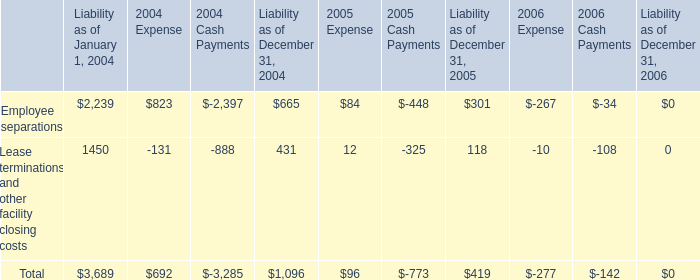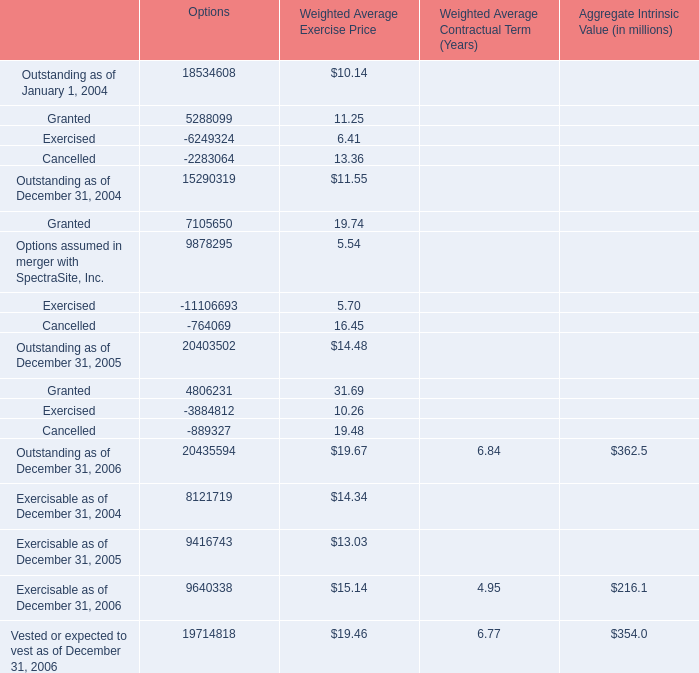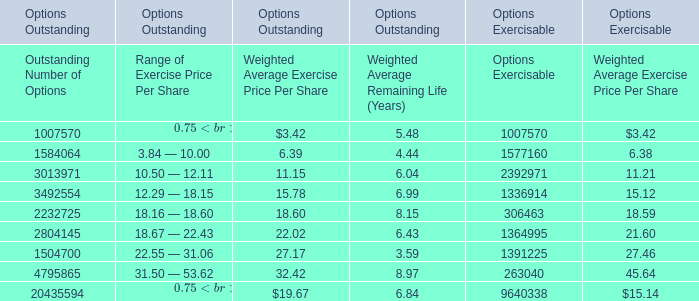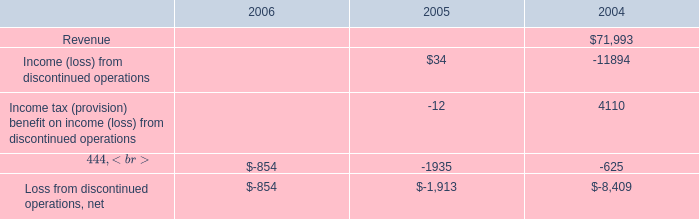Which year is options' outstanding as of December 31 the most? 
Answer: 2006. 